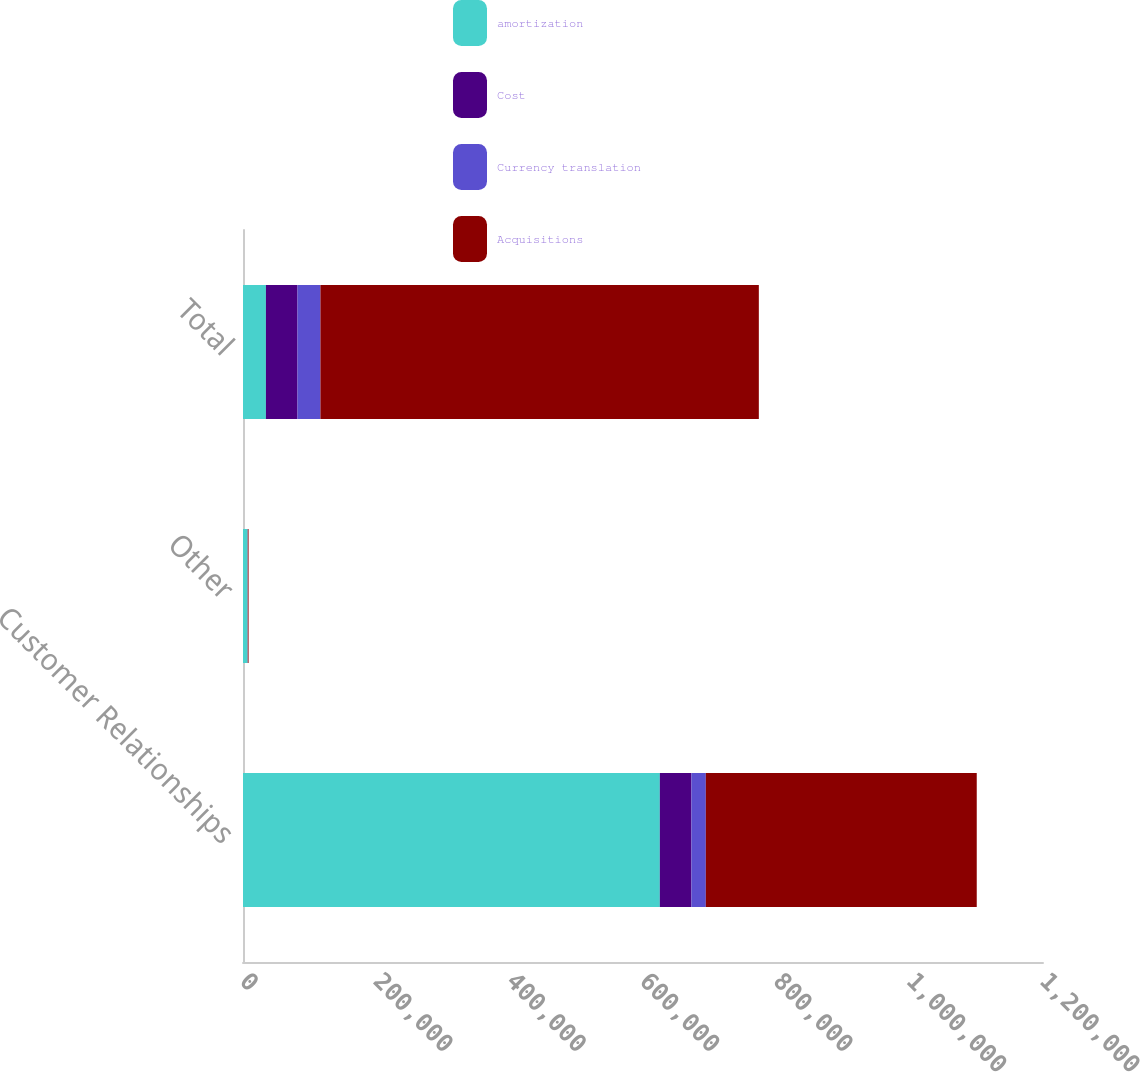<chart> <loc_0><loc_0><loc_500><loc_500><stacked_bar_chart><ecel><fcel>Customer Relationships<fcel>Other<fcel>Total<nl><fcel>amortization<fcel>625263<fcel>6825<fcel>34394<nl><fcel>Cost<fcel>47361<fcel>7<fcel>47368<nl><fcel>Currency translation<fcel>21610<fcel>298<fcel>34394<nl><fcel>Acquisitions<fcel>406386<fcel>1227<fcel>657601<nl></chart> 